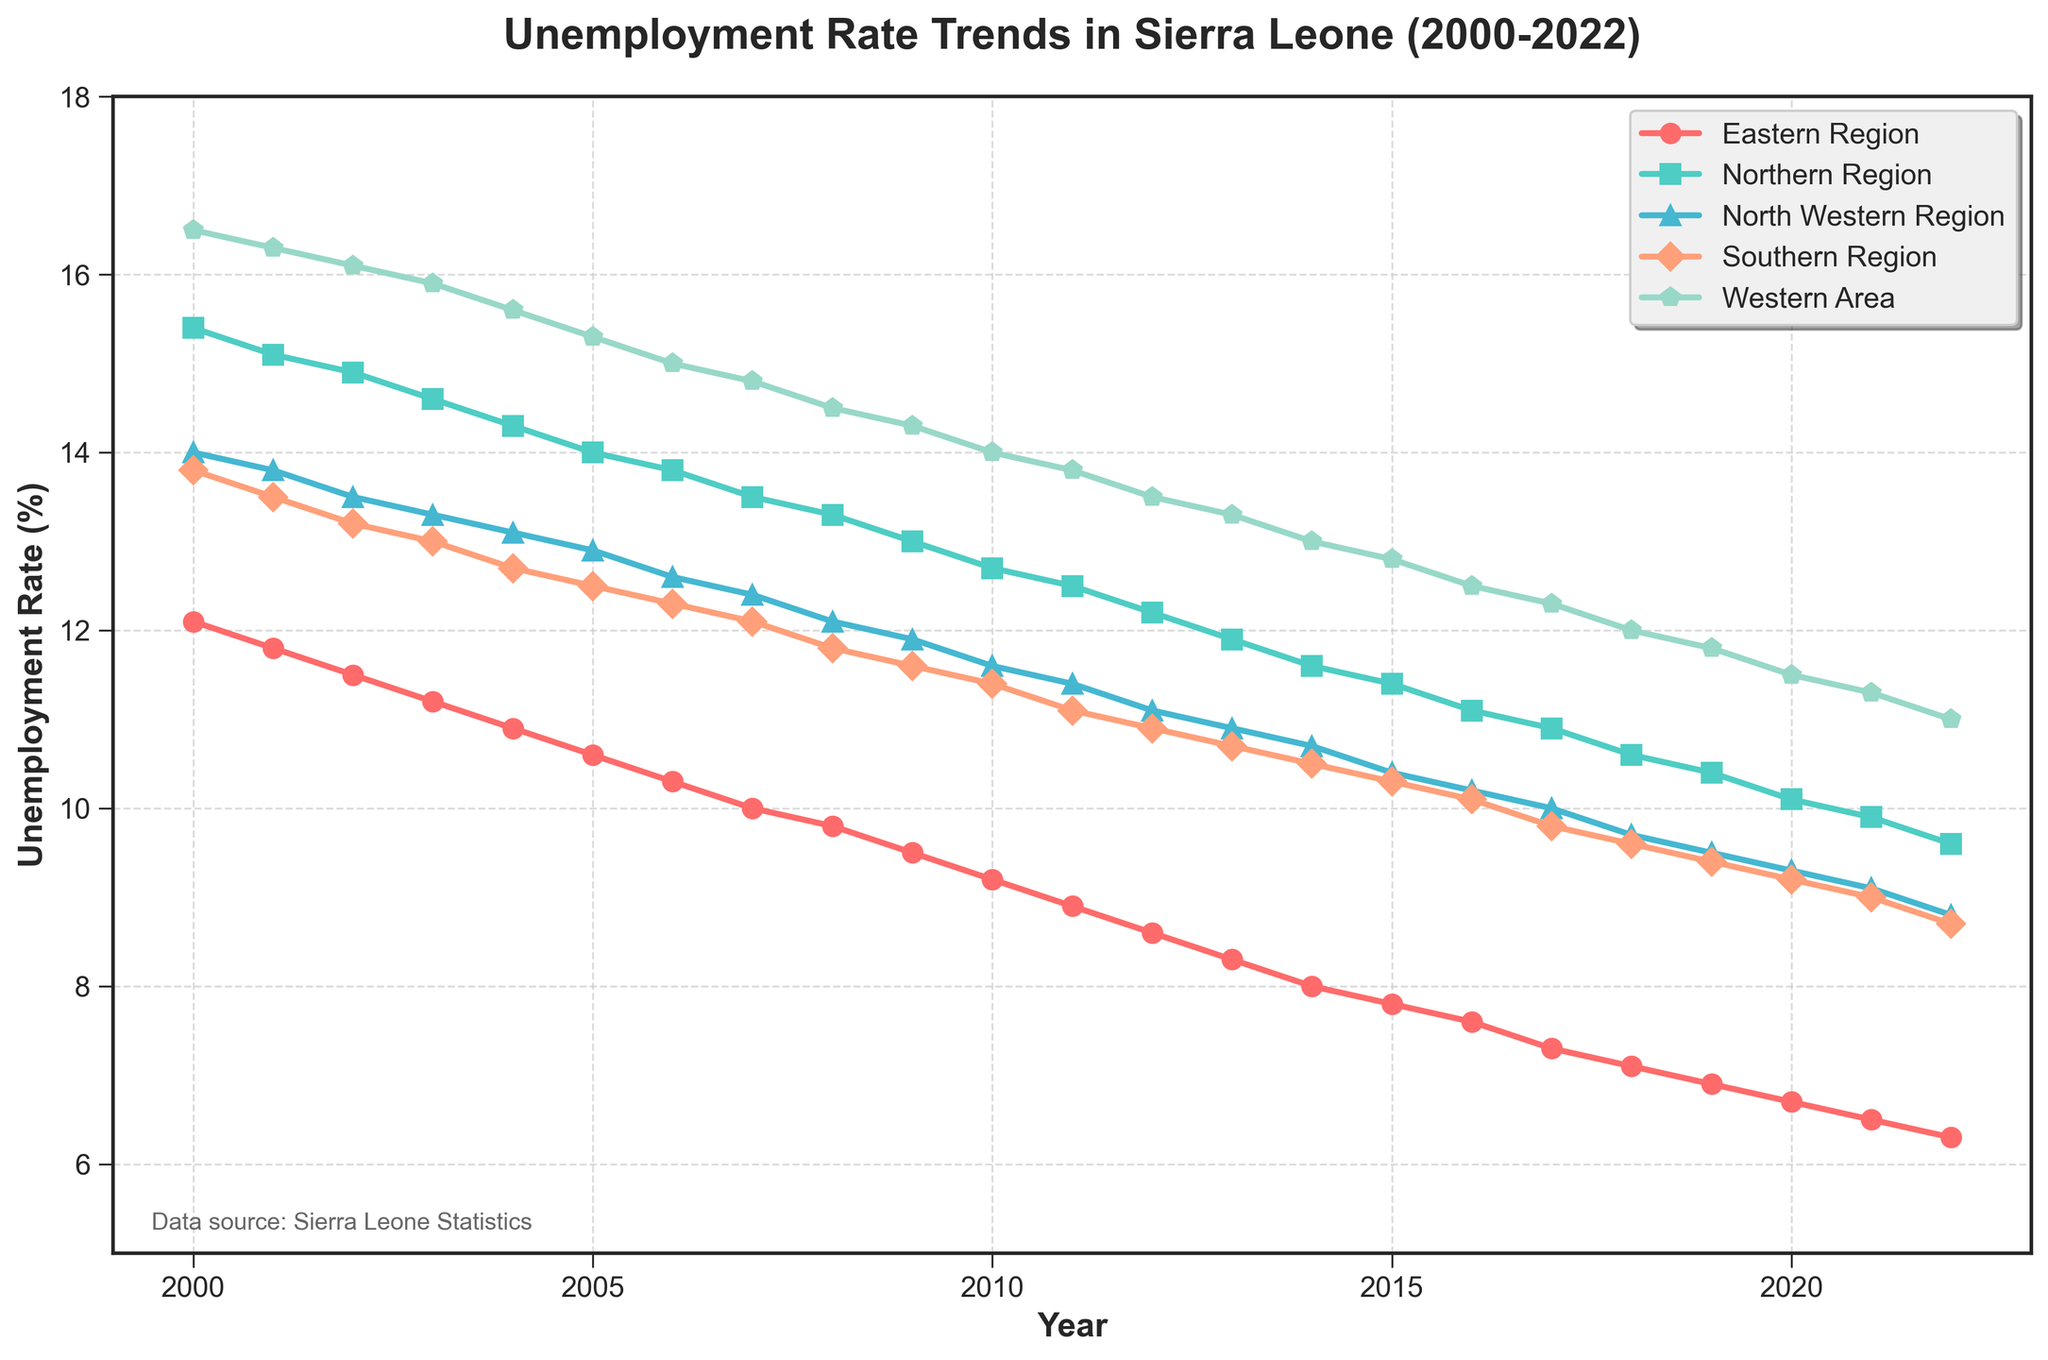What is the title of the plot? The title of the plot is typically found at the top and summarizes the data being presented. Here, it is "Unemployment Rate Trends in Sierra Leone (2000-2022)" as that text is prominently displayed at the top of the figure.
Answer: "Unemployment Rate Trends in Sierra Leone (2000-2022)" What is the unemployment rate in the Western Area in 2004? Locate the Western Area's line (usually indicated by a specific color and marker) and find the corresponding data point for the year 2004. According to the plot, the unemployment rate for the Western Area in 2004 is 15.6%.
Answer: 15.6% Which region had the highest unemployment rate in 2022? Look at the data points for the year 2022 for all regions. The Western Area has the highest unemployment rate in 2022 according to the plot.
Answer: Western Area What is the trend of unemployment rate in the Northern Region from 2000 to 2022? To determine the trend, observe the line representing the Northern Region over the given years. It consistently decreases, indicating a trend of declining unemployment rates from 2000 to 2022.
Answer: Declining Which region saw the most significant decrease in unemployment rate from 2000 to 2022? Compare the start and end values from 2000 to 2022 for each region. The Western Area dropped from 16.5% to 11.0%, a 5.5% decrease. However, the Northern Region decreased from 15.4% to 9.6%, which is a more significant drop of 5.8%. Thus, the Northern Region had the most significant decrease.
Answer: Northern Region In which year did the Southern Region see an unemployment rate below 10% for the first time? Track the Southern Region's data points across the years. In 2017, the Southern Region's unemployment rate first dips below 10%.
Answer: 2017 Compare the unemployment rates in the Eastern and Northern Regions in 2010. Which one was higher? Locate the data points for both regions in the year 2010. The plot shows the Eastern Region's rate at 9.2% and the Northern Region's rate at 12.7%. The Northern Region had the higher rate.
Answer: Northern Region What is the average unemployment rate for the North Western Region from 2010 to 2015? Find the data points for the North Western Region from 2010 to 2015 and compute the average: (11.6 + 11.4 + 11.1 + 10.9 + 10.7 + 10.4) / 6 = 11.02%.
Answer: 11.02% In which years did the Western Area have an unemployment rate greater than 15%? Identify the years in which the Western Area's data points are above 15%. These years are 2000, 2001, 2002, 2003, 2004, and 2005.
Answer: 2000, 2001, 2002, 2003, 2004, 2005 How does the unemployment rate trend of the Eastern Region compare with that of the Southern Region overall? Observe the lines for both regions from 2000 to 2022. Both show a general decline in unemployment rates, but the Southern Region's decline is slightly slower in comparison.
Answer: Both declining, Southern Region slightly slower 